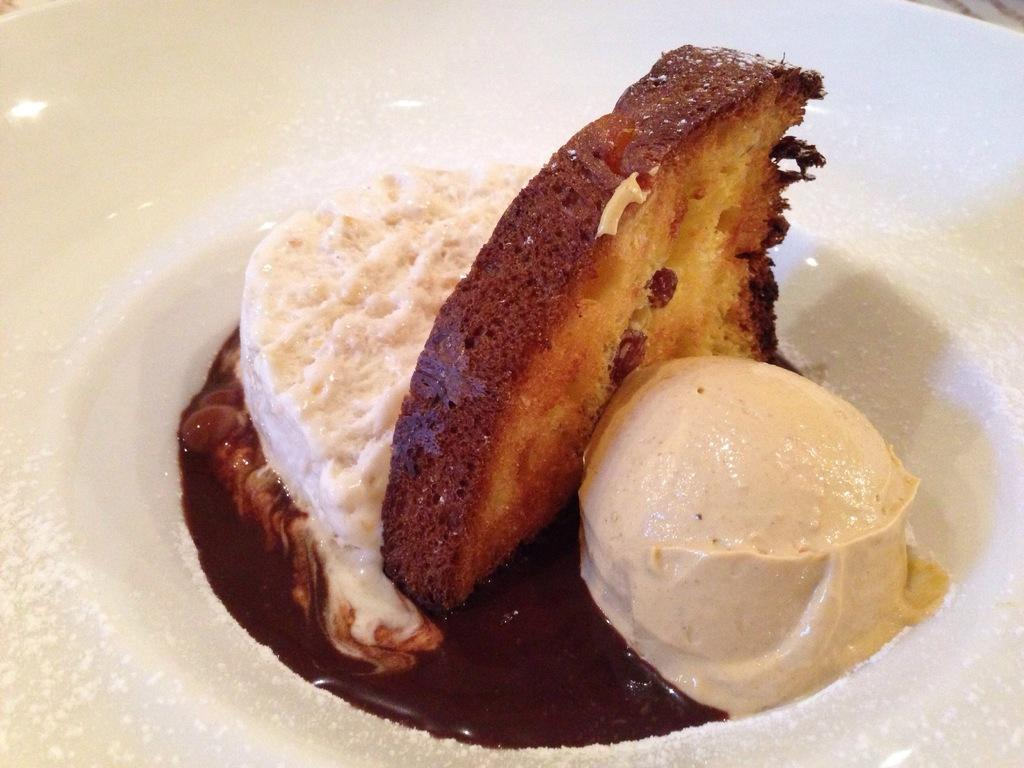What type of food is visible in the image? There is cream, bread, ice cream, and chocolate in the image. What is the color of the plate on which the items are placed? The items are on a white plate. What type of trousers can be seen in the image? There are no trousers present in the image; it features food items on a white plate. How many planes are visible in the image? There are no planes present in the image. 